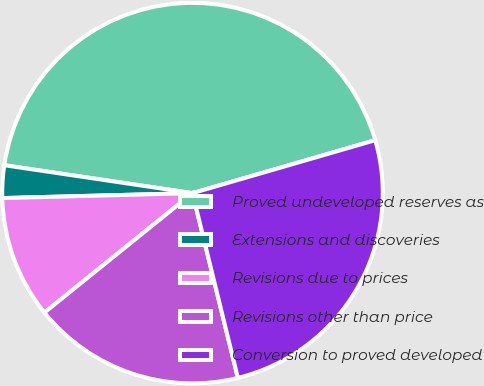Convert chart to OTSL. <chart><loc_0><loc_0><loc_500><loc_500><pie_chart><fcel>Proved undeveloped reserves as<fcel>Extensions and discoveries<fcel>Revisions due to prices<fcel>Revisions other than price<fcel>Conversion to proved developed<nl><fcel>43.17%<fcel>2.76%<fcel>10.39%<fcel>18.03%<fcel>25.66%<nl></chart> 